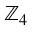<formula> <loc_0><loc_0><loc_500><loc_500>\mathbb { Z } _ { 4 }</formula> 